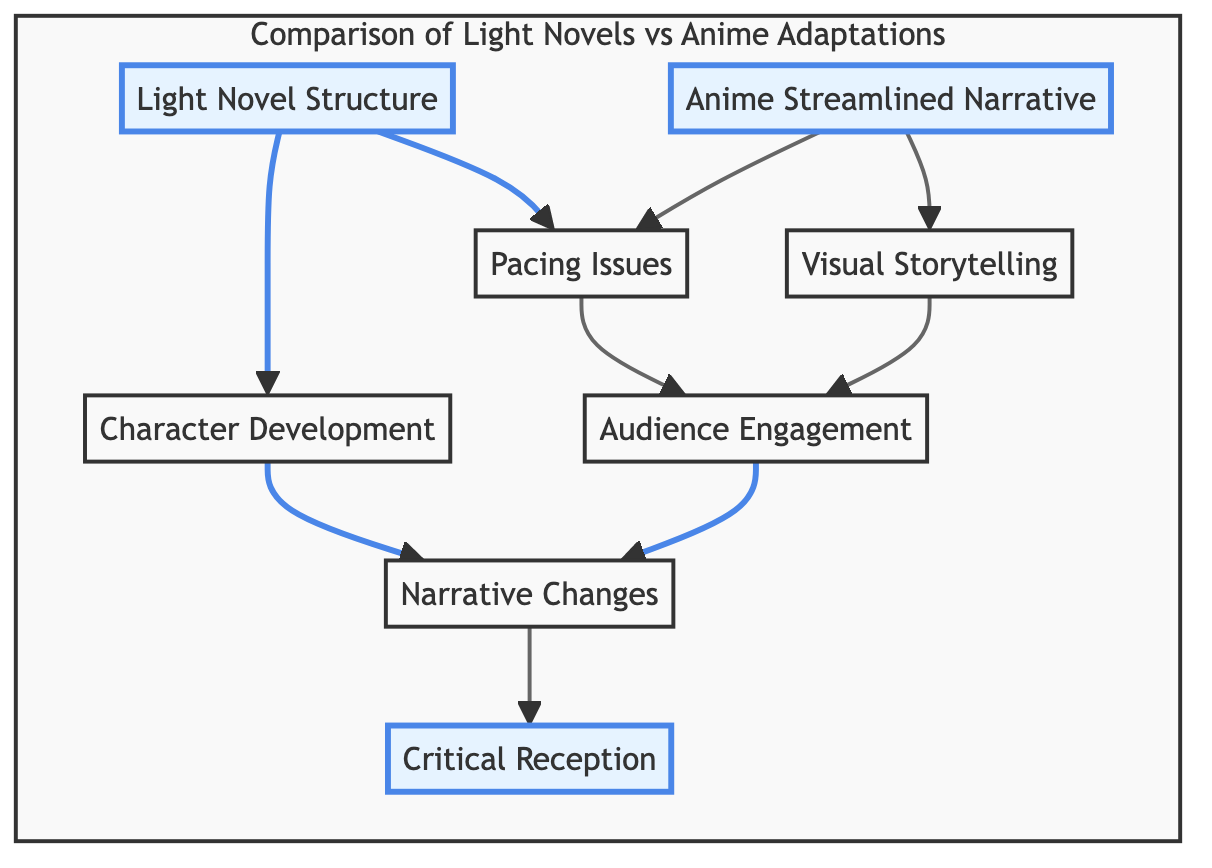What is one key characteristic of light novels highlighted in the diagram? The diagram identifies "Structural Complexity in Light Novels" as a key characteristic, emphasizing the depth that comes from richer inner monologues and character backstories.
Answer: Structural Complexity in Light Novels How does the anime adapt narrative compared to light novels? The diagram states that "Streamlined Narrative in Anime Adaptations" condenses or simplifies plots due to time constraints, distinguishing it from the more elaborate narratives found in light novels.
Answer: Streamlined Narrative in Anime Adaptations What node indicates the impact of pacing on audience engagement? The connection from "Pacing Issues" to "Audience Engagement Variations" shows that differences in pacing between light novels and anime can affect how audiences connect with the story.
Answer: Pacing Issues Which element suggests that anime adaptations may sacrifice character development? The node "Character Development Focus" illustrates that light novels provide extensive character growth, which may be compromised for faster-paced action in anime adaptations.
Answer: Character Development Focus What aspect influences how critics perceive adaptations? The diagram links "Narrative Changes Impacting Themes" to "Critical Reception," indicating that how an adaptation handles changes from the source material influences critics' views of its efficacy.
Answer: Narrative Changes Impacting Themes How do visuals in anime affect storytelling according to the diagram? The "Enhanced Visual Storytelling in Anime" node suggests that anime uses visuals and music to convey emotions, potentially altering the original narrative intent of light novels.
Answer: Enhanced Visual Storytelling in Anime How many main nodes does the diagram contain? The diagram contains eight main nodes that represent aspects of light novel and anime adaptation comparisons, such as structural complexity, narrative changes, and audience engagement.
Answer: Eight What is the relationship between narrative changes and critical reception? The diagram shows a direct link from "Narrative Changes Impacting Themes" to "Critical Reception," implying that modifications in the narrative significantly affect critical reception of anime adaptations.
Answer: Direct link 